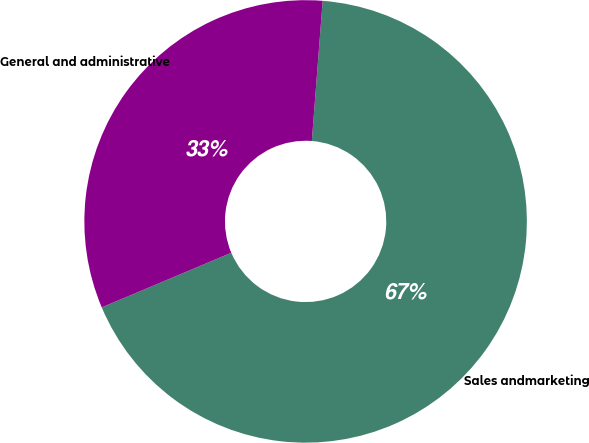Convert chart to OTSL. <chart><loc_0><loc_0><loc_500><loc_500><pie_chart><fcel>Sales andmarketing<fcel>General and administrative<nl><fcel>67.42%<fcel>32.58%<nl></chart> 